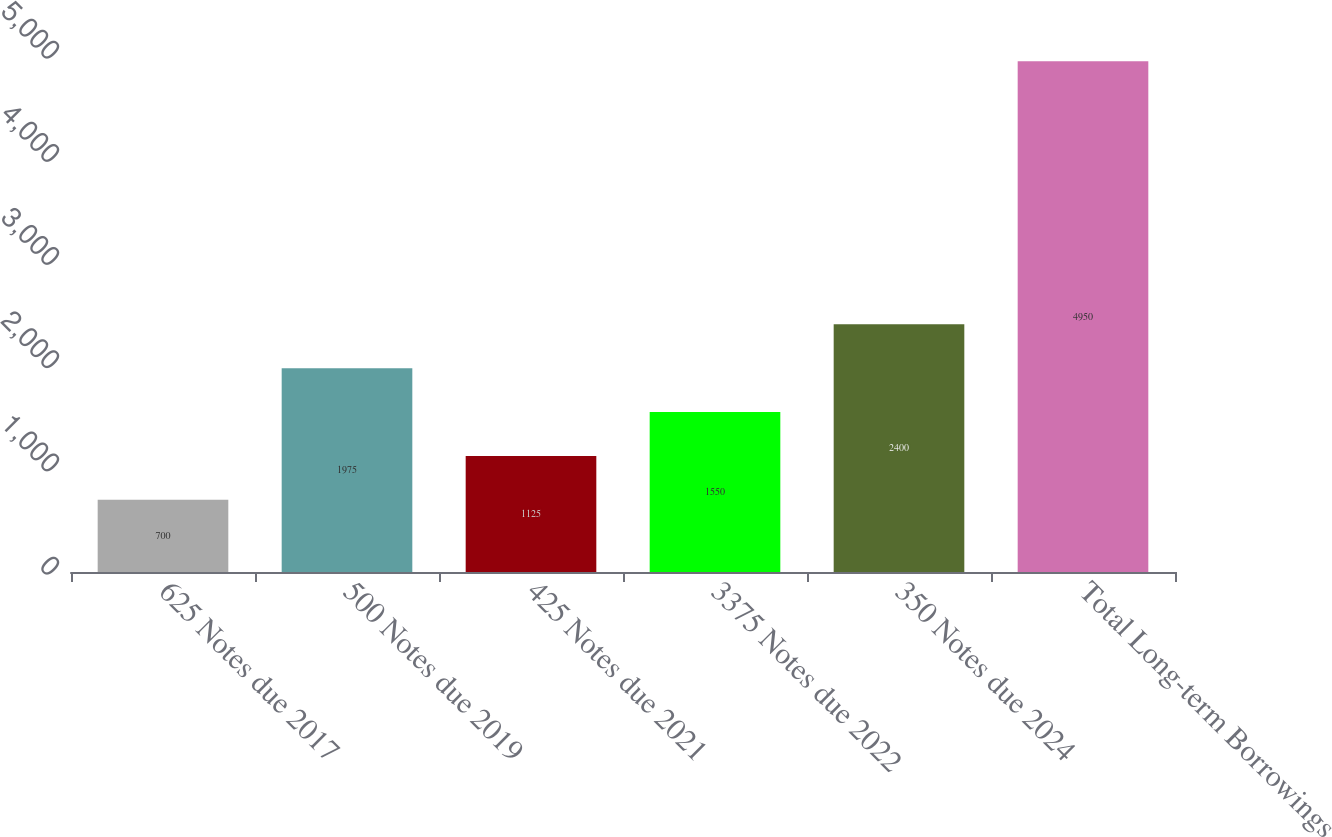Convert chart to OTSL. <chart><loc_0><loc_0><loc_500><loc_500><bar_chart><fcel>625 Notes due 2017<fcel>500 Notes due 2019<fcel>425 Notes due 2021<fcel>3375 Notes due 2022<fcel>350 Notes due 2024<fcel>Total Long-term Borrowings<nl><fcel>700<fcel>1975<fcel>1125<fcel>1550<fcel>2400<fcel>4950<nl></chart> 